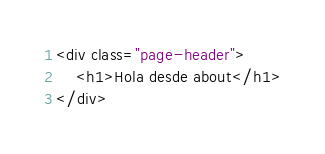Convert code to text. <code><loc_0><loc_0><loc_500><loc_500><_HTML_><div class="page-header">
    <h1>Hola desde about</h1>
</div></code> 